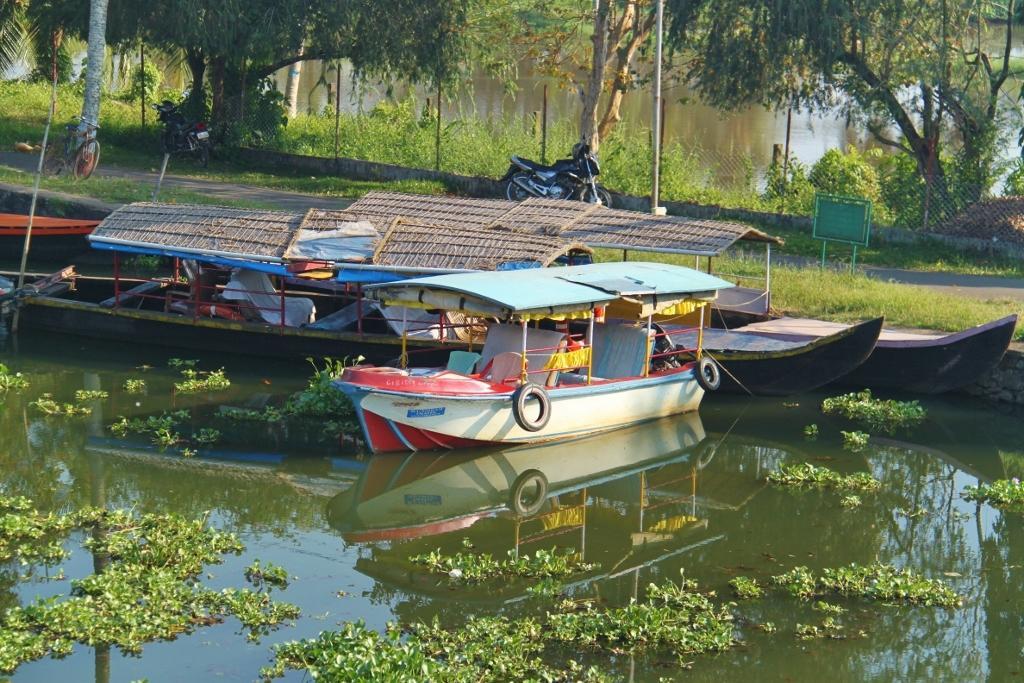Could you give a brief overview of what you see in this image? In this picture I can see boats on the water, there are vehicles on the road, there is fence, and in the background there are plants and trees. 